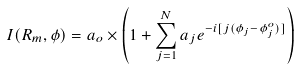Convert formula to latex. <formula><loc_0><loc_0><loc_500><loc_500>I ( R _ { m } , \phi ) = a _ { o } \times \left ( 1 + \sum _ { j = 1 } ^ { N } a _ { j } e ^ { - i [ j ( \phi _ { j } - \phi _ { j } ^ { o } ) ] } \right )</formula> 